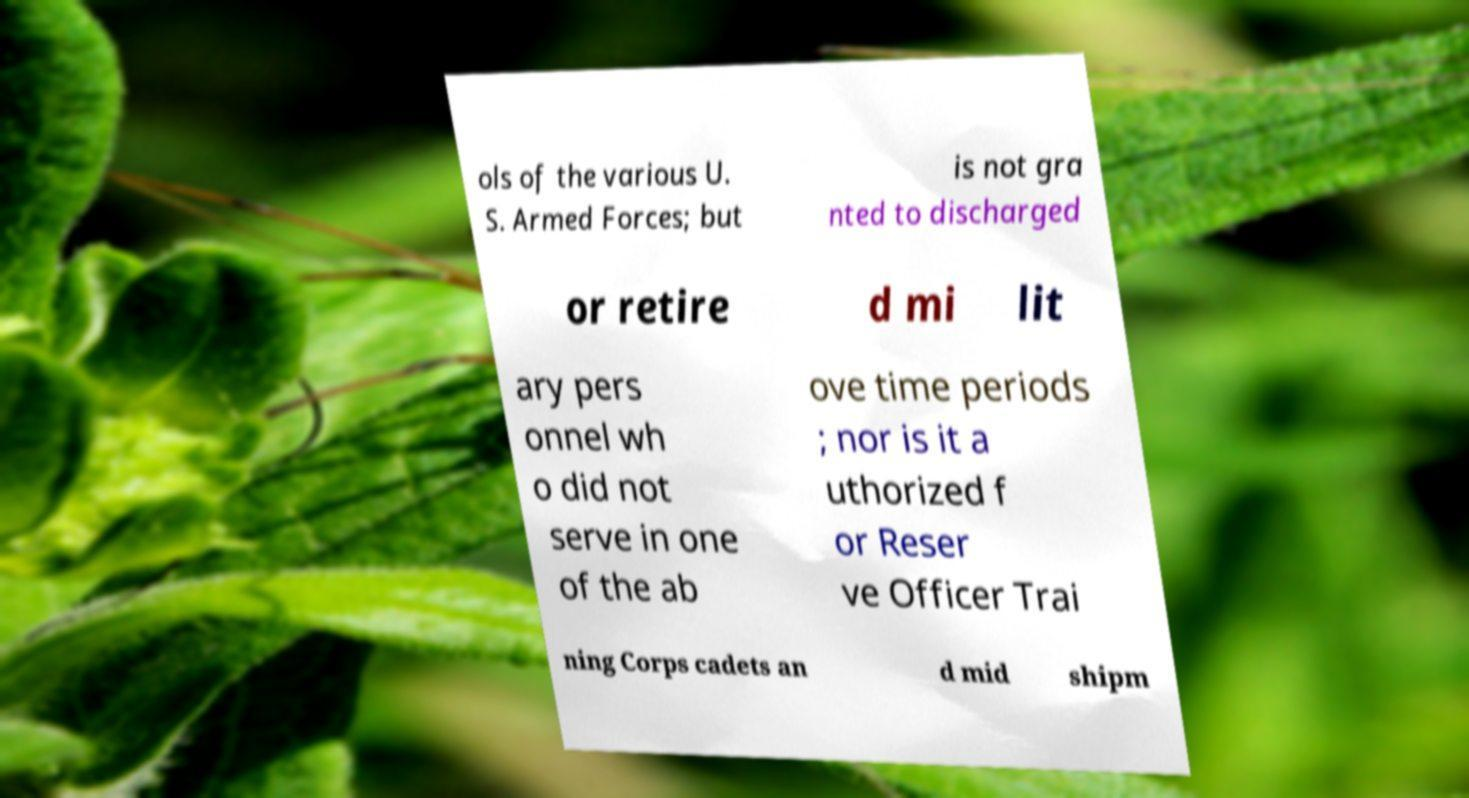For documentation purposes, I need the text within this image transcribed. Could you provide that? ols of the various U. S. Armed Forces; but is not gra nted to discharged or retire d mi lit ary pers onnel wh o did not serve in one of the ab ove time periods ; nor is it a uthorized f or Reser ve Officer Trai ning Corps cadets an d mid shipm 